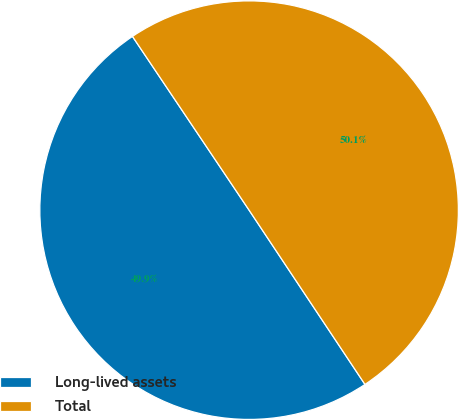<chart> <loc_0><loc_0><loc_500><loc_500><pie_chart><fcel>Long-lived assets<fcel>Total<nl><fcel>49.93%<fcel>50.07%<nl></chart> 